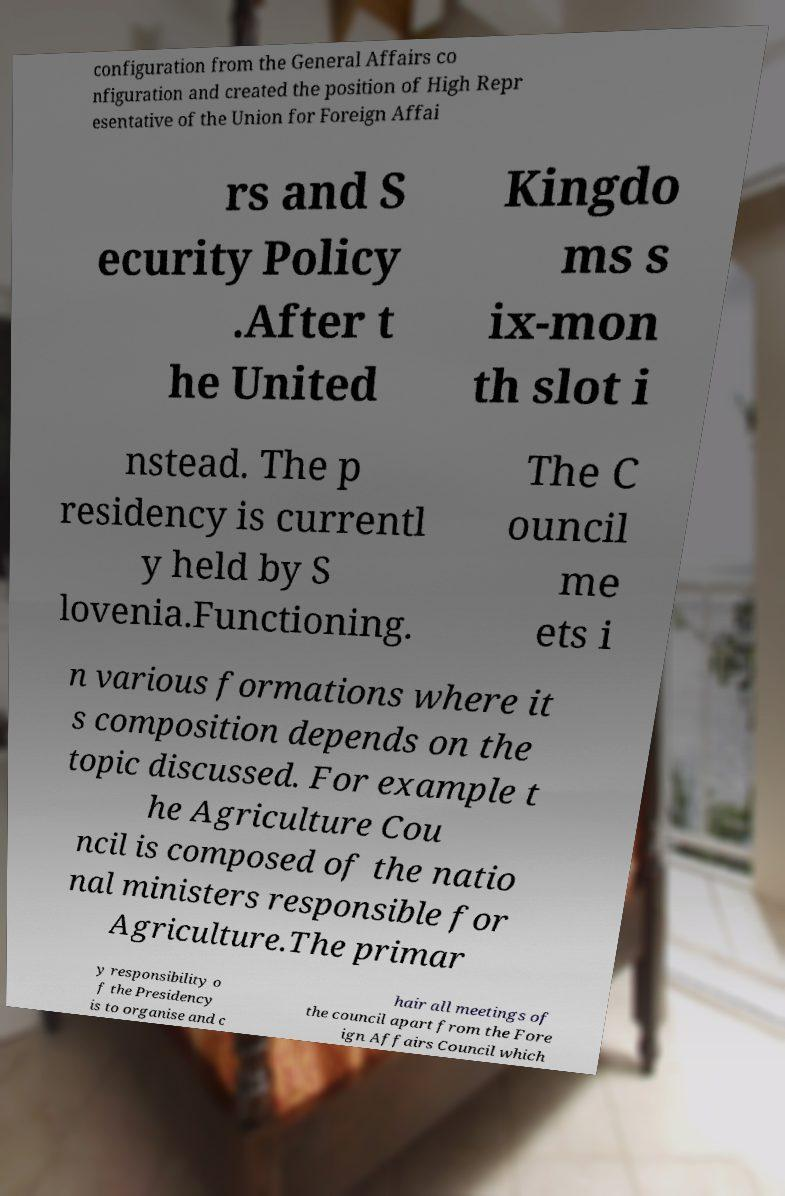Could you extract and type out the text from this image? configuration from the General Affairs co nfiguration and created the position of High Repr esentative of the Union for Foreign Affai rs and S ecurity Policy .After t he United Kingdo ms s ix-mon th slot i nstead. The p residency is currentl y held by S lovenia.Functioning. The C ouncil me ets i n various formations where it s composition depends on the topic discussed. For example t he Agriculture Cou ncil is composed of the natio nal ministers responsible for Agriculture.The primar y responsibility o f the Presidency is to organise and c hair all meetings of the council apart from the Fore ign Affairs Council which 